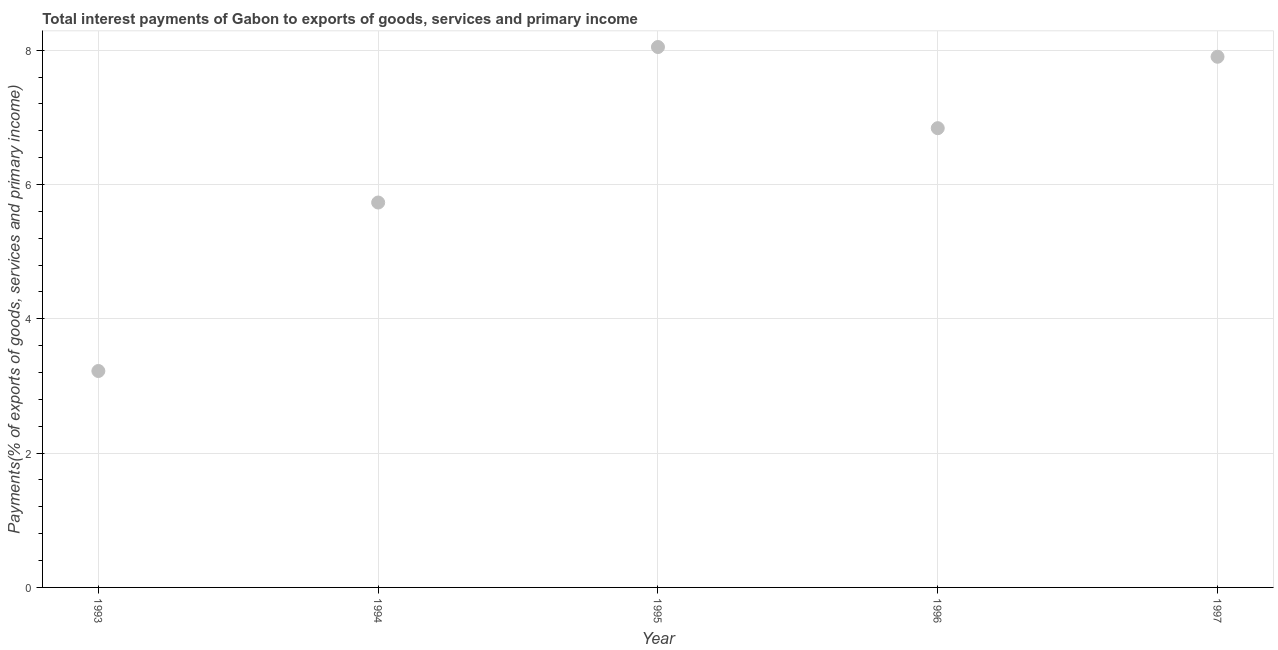What is the total interest payments on external debt in 1993?
Offer a very short reply. 3.22. Across all years, what is the maximum total interest payments on external debt?
Provide a short and direct response. 8.05. Across all years, what is the minimum total interest payments on external debt?
Offer a terse response. 3.22. In which year was the total interest payments on external debt maximum?
Keep it short and to the point. 1995. What is the sum of the total interest payments on external debt?
Your answer should be very brief. 31.74. What is the difference between the total interest payments on external debt in 1996 and 1997?
Your answer should be compact. -1.06. What is the average total interest payments on external debt per year?
Provide a short and direct response. 6.35. What is the median total interest payments on external debt?
Ensure brevity in your answer.  6.84. In how many years, is the total interest payments on external debt greater than 2.4 %?
Your response must be concise. 5. What is the ratio of the total interest payments on external debt in 1993 to that in 1995?
Keep it short and to the point. 0.4. Is the total interest payments on external debt in 1994 less than that in 1995?
Provide a short and direct response. Yes. What is the difference between the highest and the second highest total interest payments on external debt?
Your answer should be compact. 0.15. Is the sum of the total interest payments on external debt in 1995 and 1997 greater than the maximum total interest payments on external debt across all years?
Make the answer very short. Yes. What is the difference between the highest and the lowest total interest payments on external debt?
Offer a very short reply. 4.82. In how many years, is the total interest payments on external debt greater than the average total interest payments on external debt taken over all years?
Your answer should be very brief. 3. How many dotlines are there?
Your answer should be compact. 1. How many years are there in the graph?
Keep it short and to the point. 5. Does the graph contain any zero values?
Offer a very short reply. No. Does the graph contain grids?
Offer a very short reply. Yes. What is the title of the graph?
Offer a terse response. Total interest payments of Gabon to exports of goods, services and primary income. What is the label or title of the Y-axis?
Provide a succinct answer. Payments(% of exports of goods, services and primary income). What is the Payments(% of exports of goods, services and primary income) in 1993?
Give a very brief answer. 3.22. What is the Payments(% of exports of goods, services and primary income) in 1994?
Provide a short and direct response. 5.73. What is the Payments(% of exports of goods, services and primary income) in 1995?
Your response must be concise. 8.05. What is the Payments(% of exports of goods, services and primary income) in 1996?
Your answer should be very brief. 6.84. What is the Payments(% of exports of goods, services and primary income) in 1997?
Provide a short and direct response. 7.9. What is the difference between the Payments(% of exports of goods, services and primary income) in 1993 and 1994?
Your response must be concise. -2.51. What is the difference between the Payments(% of exports of goods, services and primary income) in 1993 and 1995?
Make the answer very short. -4.82. What is the difference between the Payments(% of exports of goods, services and primary income) in 1993 and 1996?
Ensure brevity in your answer.  -3.62. What is the difference between the Payments(% of exports of goods, services and primary income) in 1993 and 1997?
Ensure brevity in your answer.  -4.68. What is the difference between the Payments(% of exports of goods, services and primary income) in 1994 and 1995?
Provide a succinct answer. -2.32. What is the difference between the Payments(% of exports of goods, services and primary income) in 1994 and 1996?
Ensure brevity in your answer.  -1.11. What is the difference between the Payments(% of exports of goods, services and primary income) in 1994 and 1997?
Your answer should be compact. -2.17. What is the difference between the Payments(% of exports of goods, services and primary income) in 1995 and 1996?
Make the answer very short. 1.21. What is the difference between the Payments(% of exports of goods, services and primary income) in 1995 and 1997?
Make the answer very short. 0.15. What is the difference between the Payments(% of exports of goods, services and primary income) in 1996 and 1997?
Offer a terse response. -1.06. What is the ratio of the Payments(% of exports of goods, services and primary income) in 1993 to that in 1994?
Offer a very short reply. 0.56. What is the ratio of the Payments(% of exports of goods, services and primary income) in 1993 to that in 1996?
Offer a very short reply. 0.47. What is the ratio of the Payments(% of exports of goods, services and primary income) in 1993 to that in 1997?
Your answer should be compact. 0.41. What is the ratio of the Payments(% of exports of goods, services and primary income) in 1994 to that in 1995?
Ensure brevity in your answer.  0.71. What is the ratio of the Payments(% of exports of goods, services and primary income) in 1994 to that in 1996?
Your response must be concise. 0.84. What is the ratio of the Payments(% of exports of goods, services and primary income) in 1994 to that in 1997?
Provide a succinct answer. 0.72. What is the ratio of the Payments(% of exports of goods, services and primary income) in 1995 to that in 1996?
Your response must be concise. 1.18. What is the ratio of the Payments(% of exports of goods, services and primary income) in 1995 to that in 1997?
Ensure brevity in your answer.  1.02. What is the ratio of the Payments(% of exports of goods, services and primary income) in 1996 to that in 1997?
Keep it short and to the point. 0.86. 